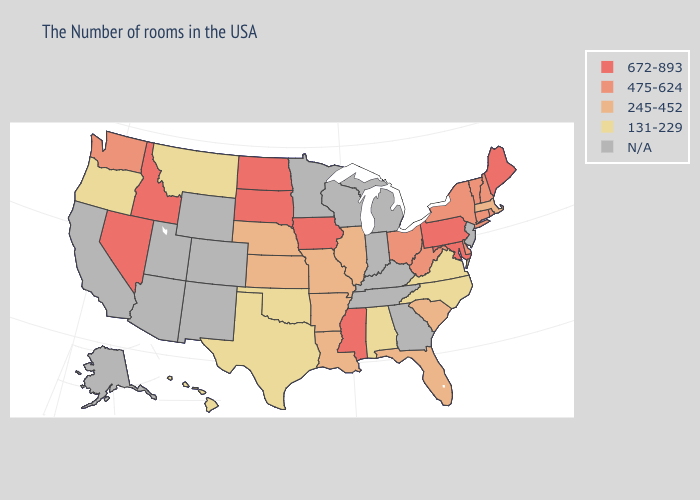What is the highest value in states that border New Hampshire?
Short answer required. 672-893. Which states have the lowest value in the South?
Keep it brief. Virginia, North Carolina, Alabama, Oklahoma, Texas. Does Connecticut have the highest value in the Northeast?
Quick response, please. No. What is the value of Idaho?
Quick response, please. 672-893. Which states have the lowest value in the South?
Be succinct. Virginia, North Carolina, Alabama, Oklahoma, Texas. Does New York have the lowest value in the Northeast?
Be succinct. No. What is the highest value in the Northeast ?
Short answer required. 672-893. What is the value of Maine?
Quick response, please. 672-893. Name the states that have a value in the range 475-624?
Quick response, please. Rhode Island, New Hampshire, Vermont, Connecticut, New York, Delaware, West Virginia, Ohio, Washington. What is the value of New Mexico?
Concise answer only. N/A. How many symbols are there in the legend?
Short answer required. 5. Name the states that have a value in the range N/A?
Answer briefly. New Jersey, Georgia, Michigan, Kentucky, Indiana, Tennessee, Wisconsin, Minnesota, Wyoming, Colorado, New Mexico, Utah, Arizona, California, Alaska. Name the states that have a value in the range N/A?
Short answer required. New Jersey, Georgia, Michigan, Kentucky, Indiana, Tennessee, Wisconsin, Minnesota, Wyoming, Colorado, New Mexico, Utah, Arizona, California, Alaska. Name the states that have a value in the range 475-624?
Concise answer only. Rhode Island, New Hampshire, Vermont, Connecticut, New York, Delaware, West Virginia, Ohio, Washington. Name the states that have a value in the range 131-229?
Give a very brief answer. Virginia, North Carolina, Alabama, Oklahoma, Texas, Montana, Oregon, Hawaii. 